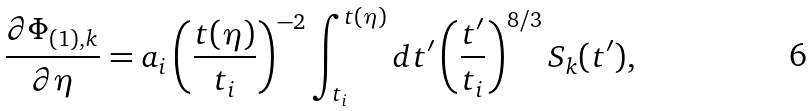Convert formula to latex. <formula><loc_0><loc_0><loc_500><loc_500>\frac { \partial \Phi _ { ( 1 ) , { k } } } { \partial \eta } = a _ { i } \left ( \frac { t ( \eta ) } { t _ { i } } \right ) ^ { - 2 } \int _ { t _ { i } } ^ { t ( \eta ) } d t ^ { \prime } \left ( \frac { t ^ { \prime } } { t _ { i } } \right ) ^ { 8 / 3 } S _ { k } ( t ^ { \prime } ) ,</formula> 